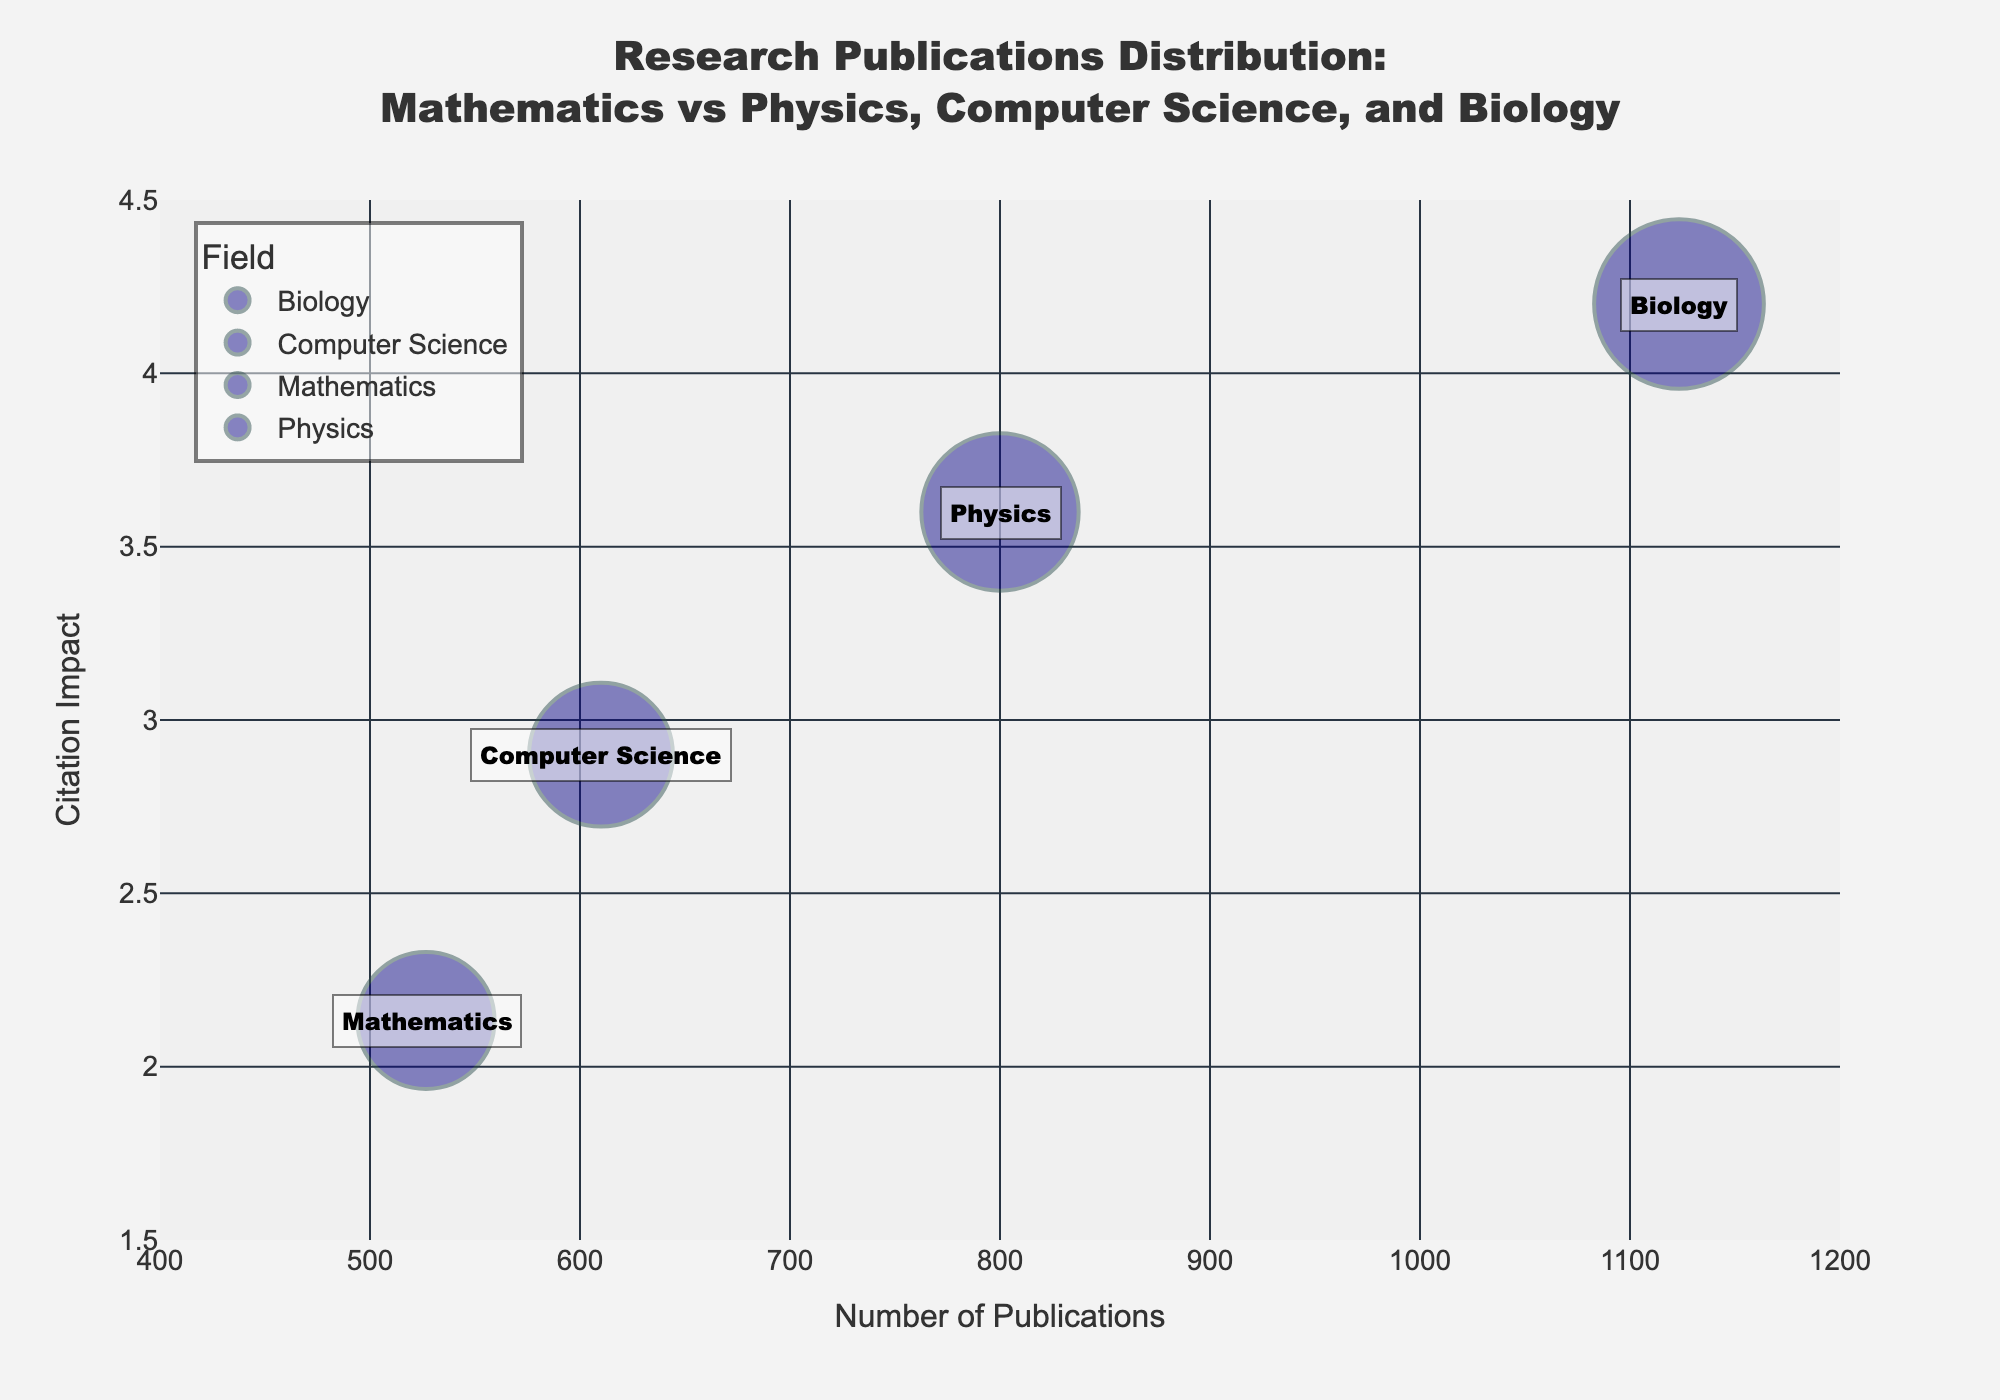What's the title of the plot? The title is a text element usually placed at the top of the plot. Here it reads, "Research Publications Distribution: Mathematics vs Physics, Computer Science, and Biology".
Answer: Research Publications Distribution: Mathematics vs Physics, Computer Science, and Biology What are the fields represented in the chart? By looking at the distinct colors and legends, the chart represents Mathematics, Physics, Computer Science, and Biology.
Answer: Mathematics, Physics, Computer Science, Biology Which field has the highest average number of publications? By observing the x-axis and the corresponding bubble location, Biology is located furthest to the right, indicating the highest average number of publications.
Answer: Biology How does the average citation impact of Mathematics compare to Physics? The bubble for Mathematics is lower on the y-axis compared to Physics, indicating that the average citation impact for Mathematics is lower than for Physics.
Answer: Lower Which field has the bubble with the largest size, indicating the highest H-index? The biggest bubble visually represents the highest H-index. The largest bubble corresponds to Biology.
Answer: Biology What is the approximate position of Computer Science in terms of number of publications and citation impact? Computer Science is located between Mathematics and Biology in terms of number of publications and citation impact, approximately around x=610 and y=2.9.
Answer: Approximately (610, 2.9) What is the average citation impact of the field with the second-highest number of publications? Physics is the field with the second-highest number of publications; its average citation impact can be identified from its bubble's y-axis position, which is around 3.6.
Answer: 3.6 Compare the H-index of Mathematics and Computer Science. Which is higher? By examining the bubble sizes where Mathematics is noticeably smaller than Computer Science, it is clear that Computer Science has a higher H-index than Mathematics.
Answer: Computer Science Which field has the least average citation impact, and roughly what is that impact? Mathematics is positioned lowest on the y-axis, indicating it has the least average citation impact, roughly around 2.1.
Answer: Mathematics, approximately 2.1 Is there a clear trend between the number of publications and the citation impact across all fields? Observing the bubbles from left to right along the x-axis, there is a noticeable trend that fields with more publications tend to have higher citation impacts.
Answer: Yes 